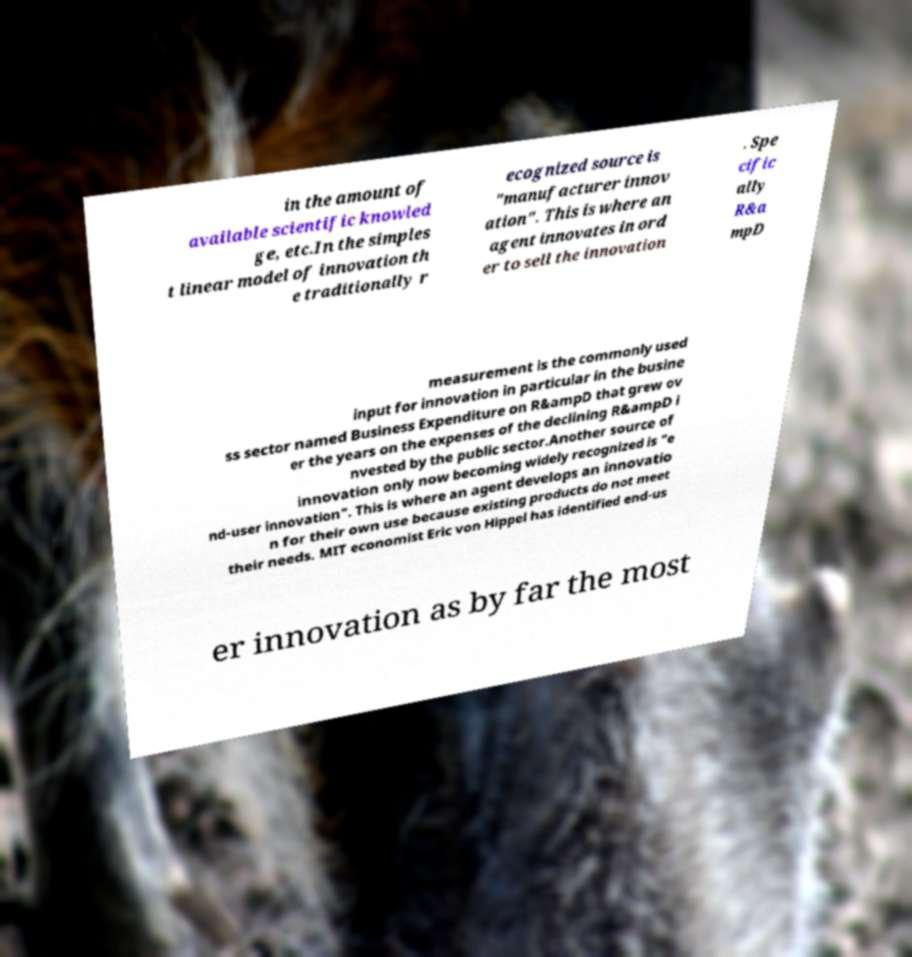There's text embedded in this image that I need extracted. Can you transcribe it verbatim? in the amount of available scientific knowled ge, etc.In the simples t linear model of innovation th e traditionally r ecognized source is "manufacturer innov ation". This is where an agent innovates in ord er to sell the innovation . Spe cific ally R&a mpD measurement is the commonly used input for innovation in particular in the busine ss sector named Business Expenditure on R&ampD that grew ov er the years on the expenses of the declining R&ampD i nvested by the public sector.Another source of innovation only now becoming widely recognized is "e nd-user innovation". This is where an agent develops an innovatio n for their own use because existing products do not meet their needs. MIT economist Eric von Hippel has identified end-us er innovation as by far the most 